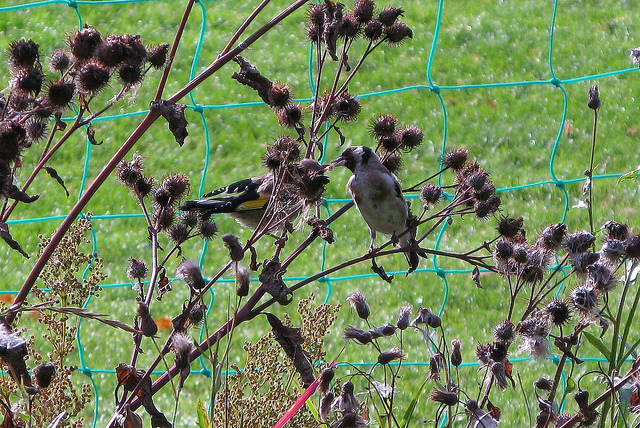Can you tell me about the blue structure and its possible function seen behind these plants? The blue structure in this image is a type of mesh or netting. It is likely used as a support system for climbing plants or as a barrier to keep birds and other animals away from a specific area, likely to protect any underlying vegetation or for the safe feeding of birds. 